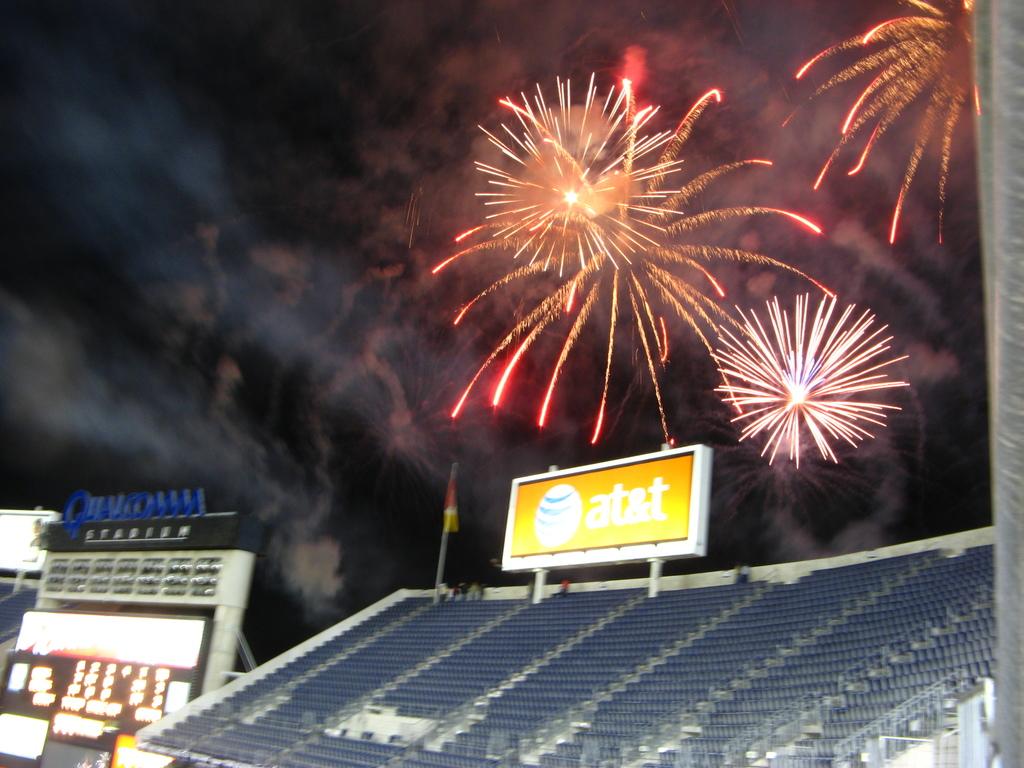What sponsor is on the billboard?
Ensure brevity in your answer.  At&t. Does at and t sponsoring these fireworks?
Your answer should be compact. Yes. 